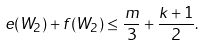Convert formula to latex. <formula><loc_0><loc_0><loc_500><loc_500>e ( W _ { 2 } ) + f ( W _ { 2 } ) \leq \frac { m } { 3 } + \frac { k + 1 } { 2 } .</formula> 